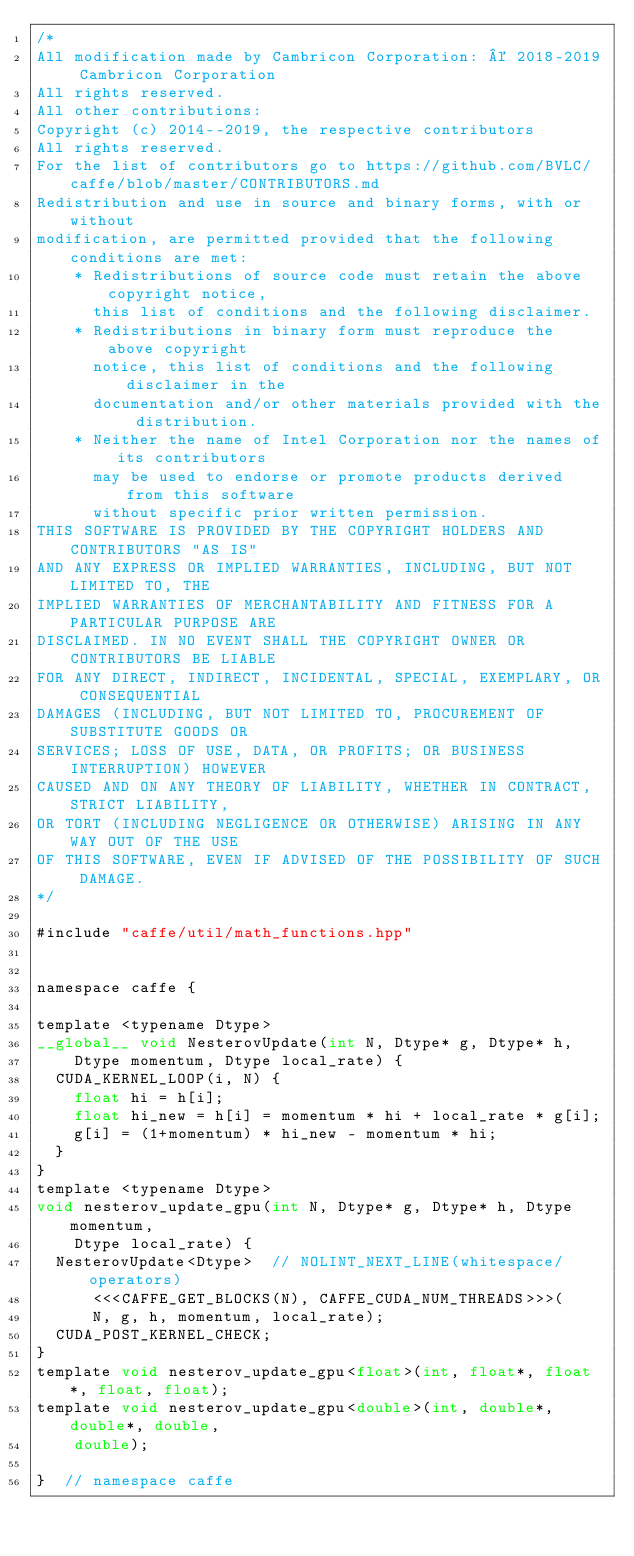<code> <loc_0><loc_0><loc_500><loc_500><_Cuda_>/*
All modification made by Cambricon Corporation: © 2018-2019 Cambricon Corporation
All rights reserved.
All other contributions:
Copyright (c) 2014--2019, the respective contributors
All rights reserved.
For the list of contributors go to https://github.com/BVLC/caffe/blob/master/CONTRIBUTORS.md
Redistribution and use in source and binary forms, with or without
modification, are permitted provided that the following conditions are met:
    * Redistributions of source code must retain the above copyright notice,
      this list of conditions and the following disclaimer.
    * Redistributions in binary form must reproduce the above copyright
      notice, this list of conditions and the following disclaimer in the
      documentation and/or other materials provided with the distribution.
    * Neither the name of Intel Corporation nor the names of its contributors
      may be used to endorse or promote products derived from this software
      without specific prior written permission.
THIS SOFTWARE IS PROVIDED BY THE COPYRIGHT HOLDERS AND CONTRIBUTORS "AS IS"
AND ANY EXPRESS OR IMPLIED WARRANTIES, INCLUDING, BUT NOT LIMITED TO, THE
IMPLIED WARRANTIES OF MERCHANTABILITY AND FITNESS FOR A PARTICULAR PURPOSE ARE
DISCLAIMED. IN NO EVENT SHALL THE COPYRIGHT OWNER OR CONTRIBUTORS BE LIABLE
FOR ANY DIRECT, INDIRECT, INCIDENTAL, SPECIAL, EXEMPLARY, OR CONSEQUENTIAL
DAMAGES (INCLUDING, BUT NOT LIMITED TO, PROCUREMENT OF SUBSTITUTE GOODS OR
SERVICES; LOSS OF USE, DATA, OR PROFITS; OR BUSINESS INTERRUPTION) HOWEVER
CAUSED AND ON ANY THEORY OF LIABILITY, WHETHER IN CONTRACT, STRICT LIABILITY,
OR TORT (INCLUDING NEGLIGENCE OR OTHERWISE) ARISING IN ANY WAY OUT OF THE USE
OF THIS SOFTWARE, EVEN IF ADVISED OF THE POSSIBILITY OF SUCH DAMAGE.
*/

#include "caffe/util/math_functions.hpp"


namespace caffe {

template <typename Dtype>
__global__ void NesterovUpdate(int N, Dtype* g, Dtype* h,
    Dtype momentum, Dtype local_rate) {
  CUDA_KERNEL_LOOP(i, N) {
    float hi = h[i];
    float hi_new = h[i] = momentum * hi + local_rate * g[i];
    g[i] = (1+momentum) * hi_new - momentum * hi;
  }
}
template <typename Dtype>
void nesterov_update_gpu(int N, Dtype* g, Dtype* h, Dtype momentum,
    Dtype local_rate) {
  NesterovUpdate<Dtype>  // NOLINT_NEXT_LINE(whitespace/operators)
      <<<CAFFE_GET_BLOCKS(N), CAFFE_CUDA_NUM_THREADS>>>(
      N, g, h, momentum, local_rate);
  CUDA_POST_KERNEL_CHECK;
}
template void nesterov_update_gpu<float>(int, float*, float*, float, float);
template void nesterov_update_gpu<double>(int, double*, double*, double,
    double);

}  // namespace caffe
</code> 